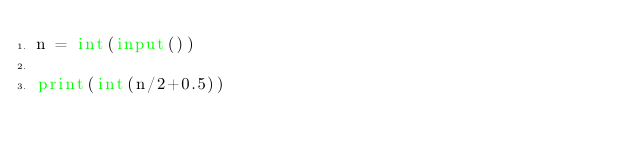<code> <loc_0><loc_0><loc_500><loc_500><_Python_>n = int(input())

print(int(n/2+0.5))</code> 